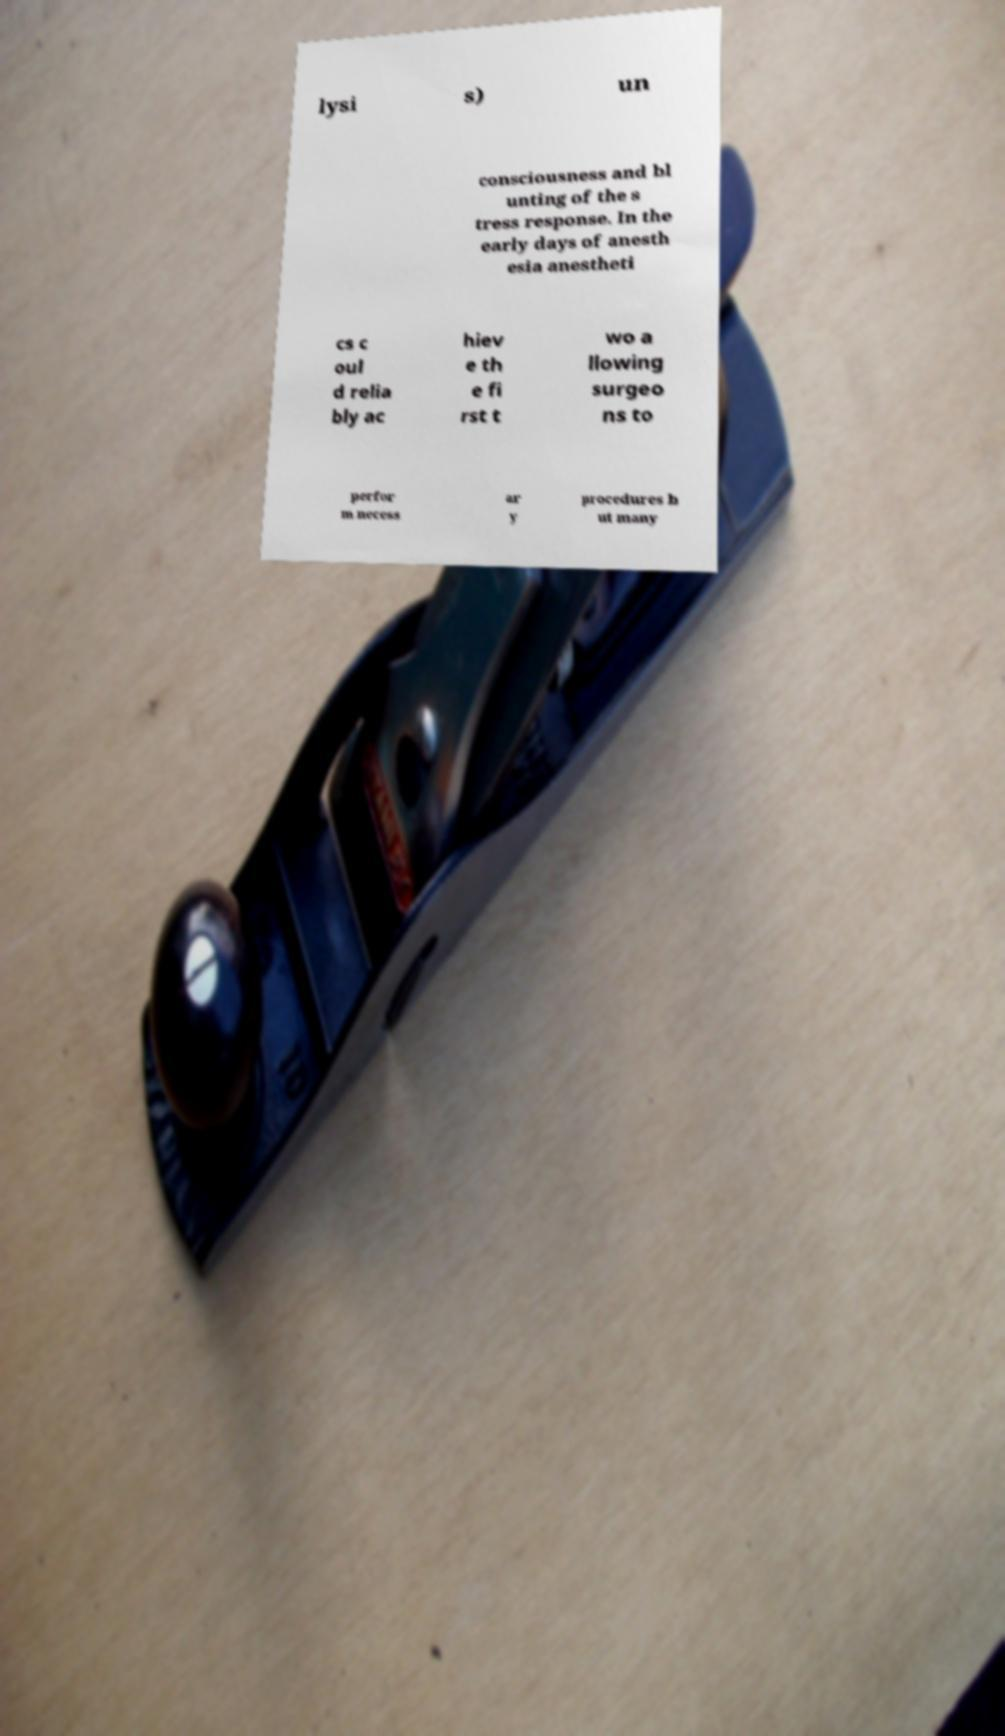Please read and relay the text visible in this image. What does it say? lysi s) un consciousness and bl unting of the s tress response. In the early days of anesth esia anestheti cs c oul d relia bly ac hiev e th e fi rst t wo a llowing surgeo ns to perfor m necess ar y procedures b ut many 